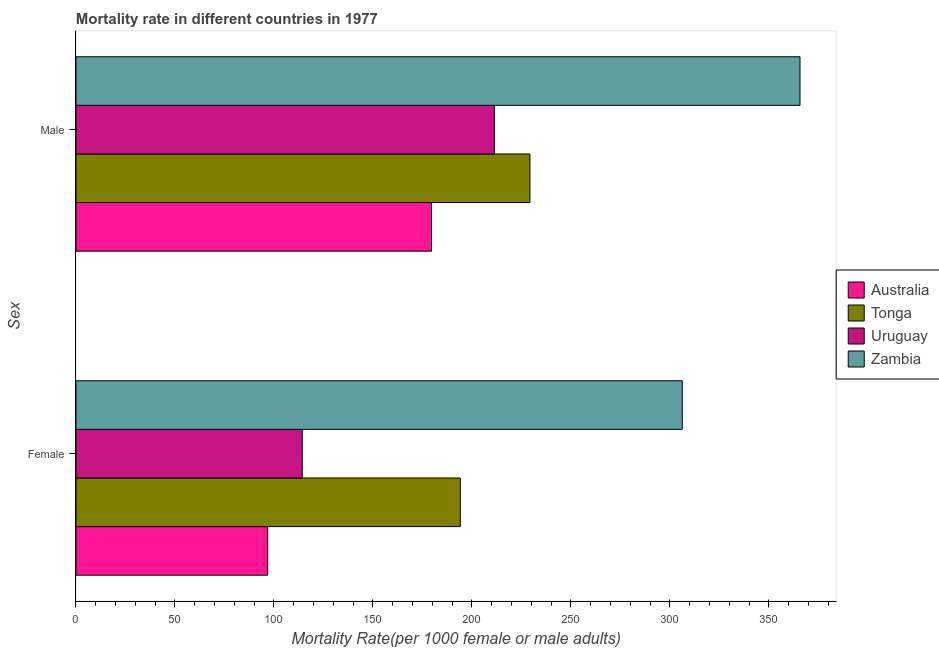How many different coloured bars are there?
Your answer should be very brief. 4. Are the number of bars on each tick of the Y-axis equal?
Keep it short and to the point. Yes. How many bars are there on the 2nd tick from the top?
Keep it short and to the point. 4. What is the label of the 1st group of bars from the top?
Ensure brevity in your answer.  Male. What is the female mortality rate in Uruguay?
Your answer should be very brief. 114.29. Across all countries, what is the maximum female mortality rate?
Make the answer very short. 306.3. Across all countries, what is the minimum male mortality rate?
Make the answer very short. 179.59. In which country was the male mortality rate maximum?
Offer a very short reply. Zambia. What is the total female mortality rate in the graph?
Ensure brevity in your answer.  711.58. What is the difference between the male mortality rate in Tonga and that in Australia?
Keep it short and to the point. 49.74. What is the difference between the male mortality rate in Australia and the female mortality rate in Zambia?
Your answer should be compact. -126.7. What is the average male mortality rate per country?
Your answer should be very brief. 246.51. What is the difference between the female mortality rate and male mortality rate in Australia?
Your response must be concise. -82.76. In how many countries, is the male mortality rate greater than 270 ?
Provide a succinct answer. 1. What is the ratio of the female mortality rate in Australia to that in Uruguay?
Give a very brief answer. 0.85. What does the 3rd bar from the top in Female represents?
Make the answer very short. Tonga. Are all the bars in the graph horizontal?
Provide a succinct answer. Yes. What is the difference between two consecutive major ticks on the X-axis?
Make the answer very short. 50. Are the values on the major ticks of X-axis written in scientific E-notation?
Offer a terse response. No. Does the graph contain grids?
Make the answer very short. No. How many legend labels are there?
Give a very brief answer. 4. What is the title of the graph?
Your answer should be compact. Mortality rate in different countries in 1977. Does "Europe(all income levels)" appear as one of the legend labels in the graph?
Your answer should be very brief. No. What is the label or title of the X-axis?
Offer a very short reply. Mortality Rate(per 1000 female or male adults). What is the label or title of the Y-axis?
Your response must be concise. Sex. What is the Mortality Rate(per 1000 female or male adults) of Australia in Female?
Offer a very short reply. 96.83. What is the Mortality Rate(per 1000 female or male adults) of Tonga in Female?
Offer a very short reply. 194.16. What is the Mortality Rate(per 1000 female or male adults) of Uruguay in Female?
Offer a very short reply. 114.29. What is the Mortality Rate(per 1000 female or male adults) in Zambia in Female?
Give a very brief answer. 306.3. What is the Mortality Rate(per 1000 female or male adults) in Australia in Male?
Keep it short and to the point. 179.59. What is the Mortality Rate(per 1000 female or male adults) in Tonga in Male?
Ensure brevity in your answer.  229.33. What is the Mortality Rate(per 1000 female or male adults) of Uruguay in Male?
Your answer should be compact. 211.36. What is the Mortality Rate(per 1000 female or male adults) in Zambia in Male?
Your response must be concise. 365.77. Across all Sex, what is the maximum Mortality Rate(per 1000 female or male adults) of Australia?
Your answer should be very brief. 179.59. Across all Sex, what is the maximum Mortality Rate(per 1000 female or male adults) in Tonga?
Ensure brevity in your answer.  229.33. Across all Sex, what is the maximum Mortality Rate(per 1000 female or male adults) in Uruguay?
Your answer should be very brief. 211.36. Across all Sex, what is the maximum Mortality Rate(per 1000 female or male adults) of Zambia?
Keep it short and to the point. 365.77. Across all Sex, what is the minimum Mortality Rate(per 1000 female or male adults) of Australia?
Make the answer very short. 96.83. Across all Sex, what is the minimum Mortality Rate(per 1000 female or male adults) of Tonga?
Keep it short and to the point. 194.16. Across all Sex, what is the minimum Mortality Rate(per 1000 female or male adults) of Uruguay?
Make the answer very short. 114.29. Across all Sex, what is the minimum Mortality Rate(per 1000 female or male adults) in Zambia?
Offer a terse response. 306.3. What is the total Mortality Rate(per 1000 female or male adults) of Australia in the graph?
Make the answer very short. 276.43. What is the total Mortality Rate(per 1000 female or male adults) in Tonga in the graph?
Provide a short and direct response. 423.49. What is the total Mortality Rate(per 1000 female or male adults) in Uruguay in the graph?
Offer a very short reply. 325.65. What is the total Mortality Rate(per 1000 female or male adults) in Zambia in the graph?
Provide a succinct answer. 672.06. What is the difference between the Mortality Rate(per 1000 female or male adults) of Australia in Female and that in Male?
Ensure brevity in your answer.  -82.76. What is the difference between the Mortality Rate(per 1000 female or male adults) in Tonga in Female and that in Male?
Make the answer very short. -35.17. What is the difference between the Mortality Rate(per 1000 female or male adults) in Uruguay in Female and that in Male?
Your response must be concise. -97.07. What is the difference between the Mortality Rate(per 1000 female or male adults) of Zambia in Female and that in Male?
Give a very brief answer. -59.47. What is the difference between the Mortality Rate(per 1000 female or male adults) in Australia in Female and the Mortality Rate(per 1000 female or male adults) in Tonga in Male?
Provide a short and direct response. -132.5. What is the difference between the Mortality Rate(per 1000 female or male adults) of Australia in Female and the Mortality Rate(per 1000 female or male adults) of Uruguay in Male?
Give a very brief answer. -114.53. What is the difference between the Mortality Rate(per 1000 female or male adults) of Australia in Female and the Mortality Rate(per 1000 female or male adults) of Zambia in Male?
Your answer should be very brief. -268.94. What is the difference between the Mortality Rate(per 1000 female or male adults) in Tonga in Female and the Mortality Rate(per 1000 female or male adults) in Uruguay in Male?
Your response must be concise. -17.2. What is the difference between the Mortality Rate(per 1000 female or male adults) in Tonga in Female and the Mortality Rate(per 1000 female or male adults) in Zambia in Male?
Your answer should be very brief. -171.61. What is the difference between the Mortality Rate(per 1000 female or male adults) of Uruguay in Female and the Mortality Rate(per 1000 female or male adults) of Zambia in Male?
Provide a short and direct response. -251.48. What is the average Mortality Rate(per 1000 female or male adults) in Australia per Sex?
Your answer should be very brief. 138.21. What is the average Mortality Rate(per 1000 female or male adults) in Tonga per Sex?
Ensure brevity in your answer.  211.74. What is the average Mortality Rate(per 1000 female or male adults) of Uruguay per Sex?
Ensure brevity in your answer.  162.83. What is the average Mortality Rate(per 1000 female or male adults) in Zambia per Sex?
Offer a terse response. 336.03. What is the difference between the Mortality Rate(per 1000 female or male adults) in Australia and Mortality Rate(per 1000 female or male adults) in Tonga in Female?
Make the answer very short. -97.32. What is the difference between the Mortality Rate(per 1000 female or male adults) in Australia and Mortality Rate(per 1000 female or male adults) in Uruguay in Female?
Ensure brevity in your answer.  -17.46. What is the difference between the Mortality Rate(per 1000 female or male adults) of Australia and Mortality Rate(per 1000 female or male adults) of Zambia in Female?
Make the answer very short. -209.46. What is the difference between the Mortality Rate(per 1000 female or male adults) in Tonga and Mortality Rate(per 1000 female or male adults) in Uruguay in Female?
Your response must be concise. 79.86. What is the difference between the Mortality Rate(per 1000 female or male adults) of Tonga and Mortality Rate(per 1000 female or male adults) of Zambia in Female?
Give a very brief answer. -112.14. What is the difference between the Mortality Rate(per 1000 female or male adults) in Uruguay and Mortality Rate(per 1000 female or male adults) in Zambia in Female?
Offer a terse response. -192. What is the difference between the Mortality Rate(per 1000 female or male adults) in Australia and Mortality Rate(per 1000 female or male adults) in Tonga in Male?
Offer a terse response. -49.74. What is the difference between the Mortality Rate(per 1000 female or male adults) in Australia and Mortality Rate(per 1000 female or male adults) in Uruguay in Male?
Provide a succinct answer. -31.77. What is the difference between the Mortality Rate(per 1000 female or male adults) in Australia and Mortality Rate(per 1000 female or male adults) in Zambia in Male?
Give a very brief answer. -186.18. What is the difference between the Mortality Rate(per 1000 female or male adults) in Tonga and Mortality Rate(per 1000 female or male adults) in Uruguay in Male?
Provide a succinct answer. 17.97. What is the difference between the Mortality Rate(per 1000 female or male adults) of Tonga and Mortality Rate(per 1000 female or male adults) of Zambia in Male?
Your answer should be compact. -136.44. What is the difference between the Mortality Rate(per 1000 female or male adults) of Uruguay and Mortality Rate(per 1000 female or male adults) of Zambia in Male?
Give a very brief answer. -154.41. What is the ratio of the Mortality Rate(per 1000 female or male adults) of Australia in Female to that in Male?
Your response must be concise. 0.54. What is the ratio of the Mortality Rate(per 1000 female or male adults) in Tonga in Female to that in Male?
Provide a short and direct response. 0.85. What is the ratio of the Mortality Rate(per 1000 female or male adults) in Uruguay in Female to that in Male?
Provide a short and direct response. 0.54. What is the ratio of the Mortality Rate(per 1000 female or male adults) in Zambia in Female to that in Male?
Your answer should be compact. 0.84. What is the difference between the highest and the second highest Mortality Rate(per 1000 female or male adults) of Australia?
Keep it short and to the point. 82.76. What is the difference between the highest and the second highest Mortality Rate(per 1000 female or male adults) of Tonga?
Your response must be concise. 35.17. What is the difference between the highest and the second highest Mortality Rate(per 1000 female or male adults) of Uruguay?
Offer a very short reply. 97.07. What is the difference between the highest and the second highest Mortality Rate(per 1000 female or male adults) of Zambia?
Provide a short and direct response. 59.47. What is the difference between the highest and the lowest Mortality Rate(per 1000 female or male adults) in Australia?
Keep it short and to the point. 82.76. What is the difference between the highest and the lowest Mortality Rate(per 1000 female or male adults) in Tonga?
Your response must be concise. 35.17. What is the difference between the highest and the lowest Mortality Rate(per 1000 female or male adults) in Uruguay?
Ensure brevity in your answer.  97.07. What is the difference between the highest and the lowest Mortality Rate(per 1000 female or male adults) of Zambia?
Ensure brevity in your answer.  59.47. 